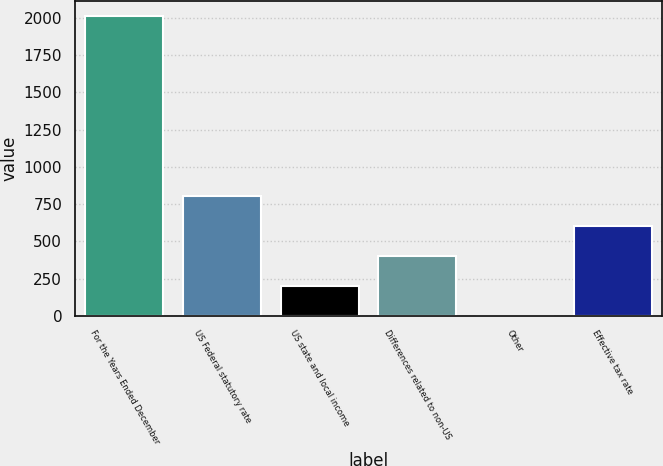Convert chart to OTSL. <chart><loc_0><loc_0><loc_500><loc_500><bar_chart><fcel>For the Years Ended December<fcel>US Federal statutory rate<fcel>US state and local income<fcel>Differences related to non-US<fcel>Other<fcel>Effective tax rate<nl><fcel>2013<fcel>805.8<fcel>202.2<fcel>403.4<fcel>1<fcel>604.6<nl></chart> 